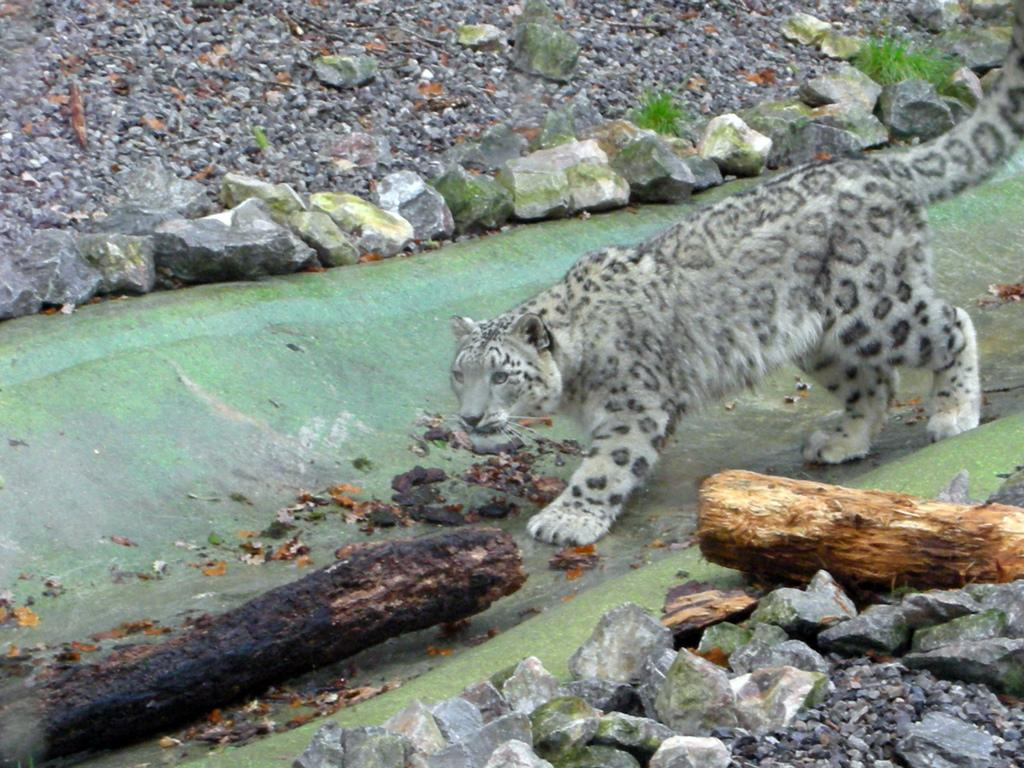What animal is present in the image? There is a cheetah in the image. What is the cheetah doing in the image? The cheetah is walking on the ground in the image. What type of objects can be seen at the bottom of the image? There are stones and sticks at the bottom of the image. What type of objects can be seen at the top of the image? There are stones visible at the top of the image. What type of calendar is hanging on the tree in the image? There is no calendar present in the image. 